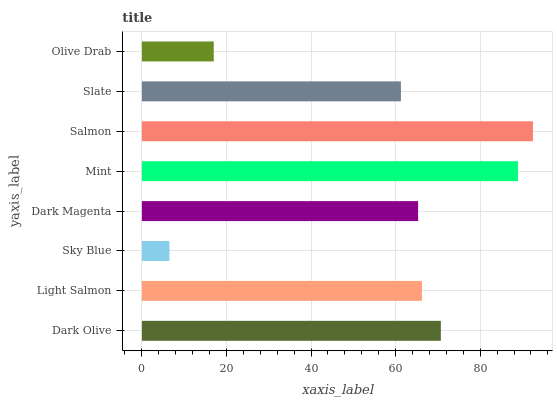Is Sky Blue the minimum?
Answer yes or no. Yes. Is Salmon the maximum?
Answer yes or no. Yes. Is Light Salmon the minimum?
Answer yes or no. No. Is Light Salmon the maximum?
Answer yes or no. No. Is Dark Olive greater than Light Salmon?
Answer yes or no. Yes. Is Light Salmon less than Dark Olive?
Answer yes or no. Yes. Is Light Salmon greater than Dark Olive?
Answer yes or no. No. Is Dark Olive less than Light Salmon?
Answer yes or no. No. Is Light Salmon the high median?
Answer yes or no. Yes. Is Dark Magenta the low median?
Answer yes or no. Yes. Is Dark Olive the high median?
Answer yes or no. No. Is Mint the low median?
Answer yes or no. No. 